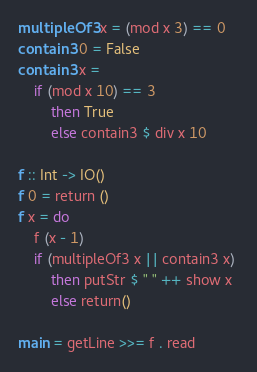<code> <loc_0><loc_0><loc_500><loc_500><_Haskell_>multipleOf3 x = (mod x 3) == 0
contain3 0 = False
contain3 x =
    if (mod x 10) == 3 
        then True
        else contain3 $ div x 10

f :: Int -> IO()
f 0 = return ()
f x = do
    f (x - 1)
    if (multipleOf3 x || contain3 x) 
        then putStr $ " " ++ show x 
        else return()

main = getLine >>= f . read
</code> 